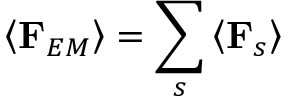Convert formula to latex. <formula><loc_0><loc_0><loc_500><loc_500>\left \langle F _ { E M } \right \rangle = \sum _ { s } \left \langle F _ { s } \right \rangle</formula> 